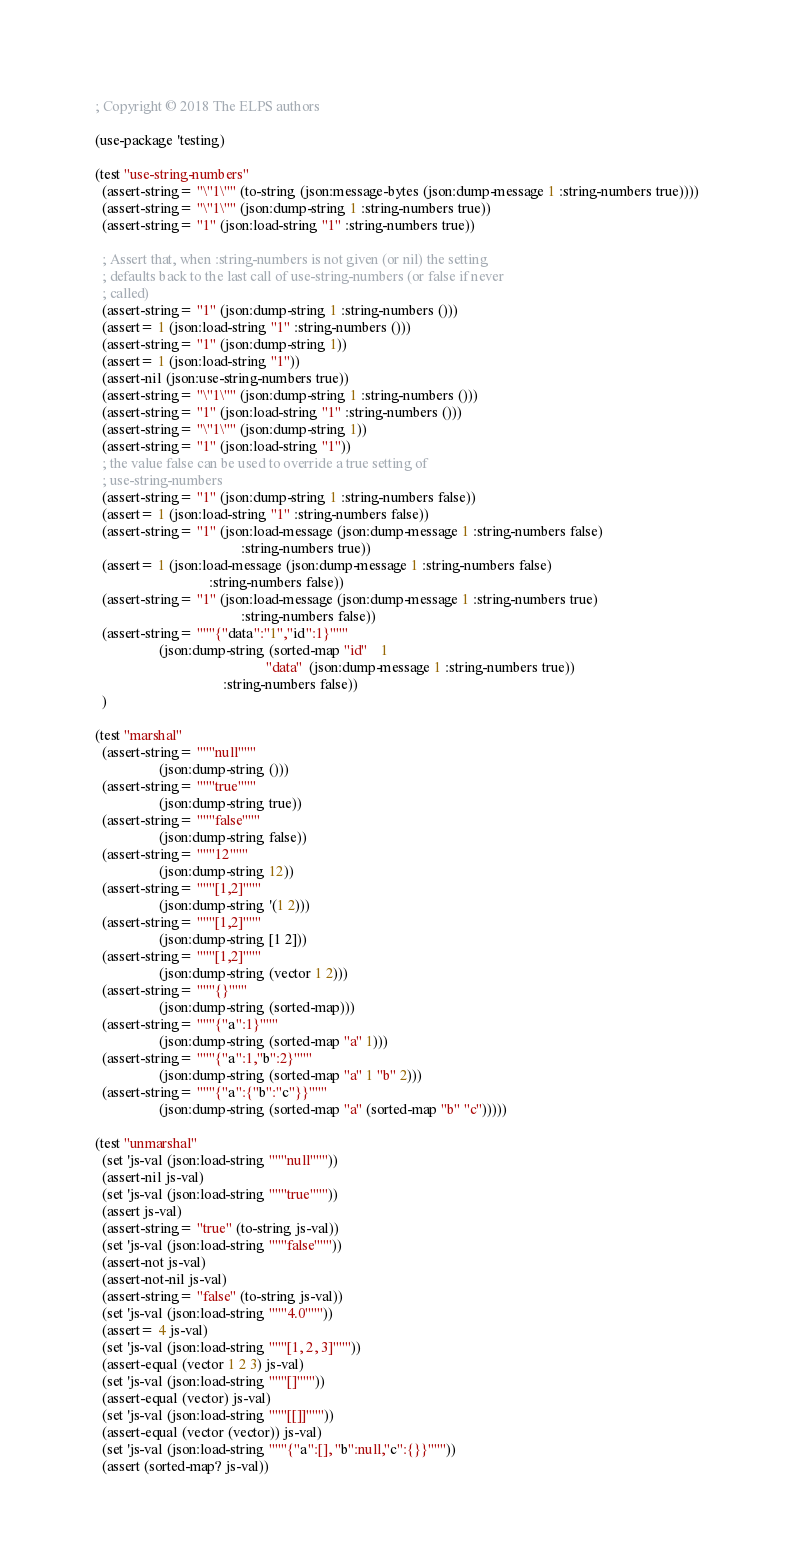Convert code to text. <code><loc_0><loc_0><loc_500><loc_500><_Lisp_>; Copyright © 2018 The ELPS authors

(use-package 'testing)

(test "use-string-numbers"
  (assert-string= "\"1\"" (to-string (json:message-bytes (json:dump-message 1 :string-numbers true))))
  (assert-string= "\"1\"" (json:dump-string 1 :string-numbers true))
  (assert-string= "1" (json:load-string "1" :string-numbers true))

  ; Assert that, when :string-numbers is not given (or nil) the setting
  ; defaults back to the last call of use-string-numbers (or false if never
  ; called)
  (assert-string= "1" (json:dump-string 1 :string-numbers ()))
  (assert= 1 (json:load-string "1" :string-numbers ()))
  (assert-string= "1" (json:dump-string 1))
  (assert= 1 (json:load-string "1"))
  (assert-nil (json:use-string-numbers true))
  (assert-string= "\"1\"" (json:dump-string 1 :string-numbers ()))
  (assert-string= "1" (json:load-string "1" :string-numbers ()))
  (assert-string= "\"1\"" (json:dump-string 1))
  (assert-string= "1" (json:load-string "1"))
  ; the value false can be used to override a true setting of
  ; use-string-numbers
  (assert-string= "1" (json:dump-string 1 :string-numbers false))
  (assert= 1 (json:load-string "1" :string-numbers false))
  (assert-string= "1" (json:load-message (json:dump-message 1 :string-numbers false)
                                         :string-numbers true))
  (assert= 1 (json:load-message (json:dump-message 1 :string-numbers false)
                                :string-numbers false))
  (assert-string= "1" (json:load-message (json:dump-message 1 :string-numbers true)
                                         :string-numbers false))
  (assert-string= """{"data":"1","id":1}"""
                  (json:dump-string (sorted-map "id"    1
                                                "data"  (json:dump-message 1 :string-numbers true))
                                    :string-numbers false))
  )

(test "marshal"
  (assert-string= """null"""
                  (json:dump-string ()))
  (assert-string= """true"""
                  (json:dump-string true))
  (assert-string= """false"""
                  (json:dump-string false))
  (assert-string= """12"""
                  (json:dump-string 12))
  (assert-string= """[1,2]"""
                  (json:dump-string '(1 2)))
  (assert-string= """[1,2]"""
                  (json:dump-string [1 2]))
  (assert-string= """[1,2]"""
                  (json:dump-string (vector 1 2)))
  (assert-string= """{}"""
                  (json:dump-string (sorted-map)))
  (assert-string= """{"a":1}"""
                  (json:dump-string (sorted-map "a" 1)))
  (assert-string= """{"a":1,"b":2}"""
                  (json:dump-string (sorted-map "a" 1 "b" 2)))
  (assert-string= """{"a":{"b":"c"}}"""
                  (json:dump-string (sorted-map "a" (sorted-map "b" "c")))))

(test "unmarshal"
  (set 'js-val (json:load-string """null"""))
  (assert-nil js-val)
  (set 'js-val (json:load-string """true"""))
  (assert js-val)
  (assert-string= "true" (to-string js-val))
  (set 'js-val (json:load-string """false"""))
  (assert-not js-val)
  (assert-not-nil js-val)
  (assert-string= "false" (to-string js-val))
  (set 'js-val (json:load-string """4.0"""))
  (assert= 4 js-val)
  (set 'js-val (json:load-string """[1, 2, 3]"""))
  (assert-equal (vector 1 2 3) js-val)
  (set 'js-val (json:load-string """[]"""))
  (assert-equal (vector) js-val)
  (set 'js-val (json:load-string """[[]]"""))
  (assert-equal (vector (vector)) js-val)
  (set 'js-val (json:load-string """{"a":[], "b":null,"c":{}}"""))
  (assert (sorted-map? js-val))</code> 